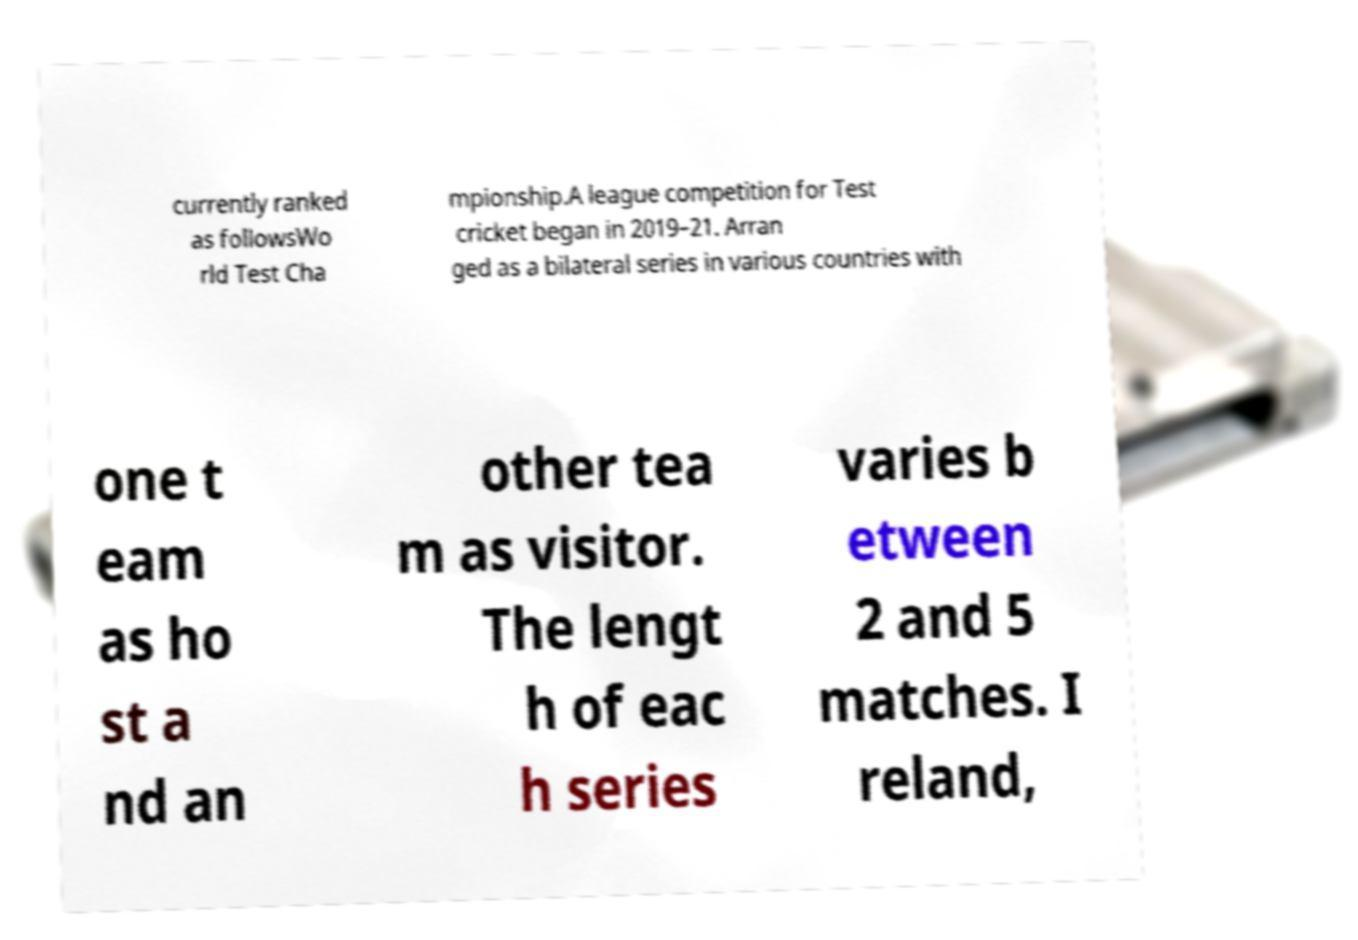Could you assist in decoding the text presented in this image and type it out clearly? currently ranked as followsWo rld Test Cha mpionship.A league competition for Test cricket began in 2019–21. Arran ged as a bilateral series in various countries with one t eam as ho st a nd an other tea m as visitor. The lengt h of eac h series varies b etween 2 and 5 matches. I reland, 